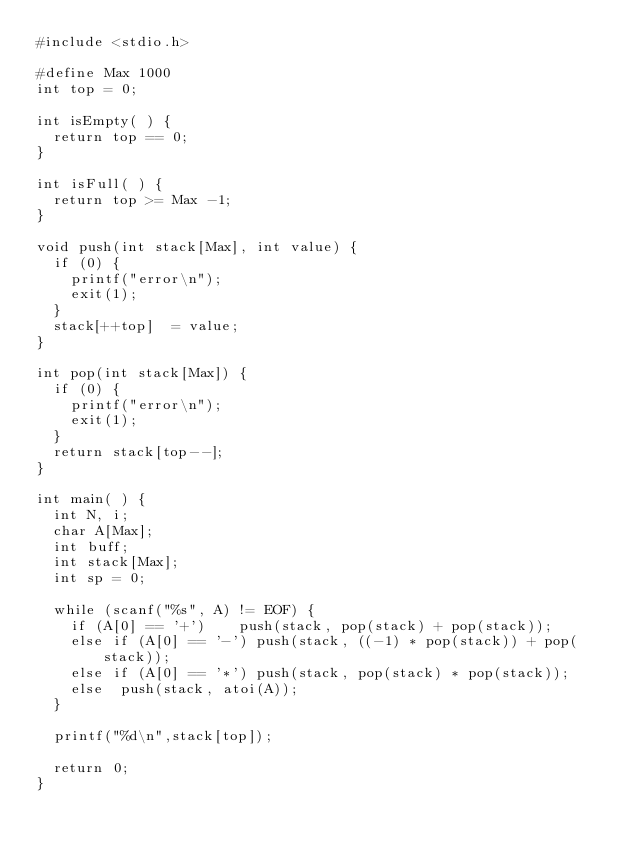<code> <loc_0><loc_0><loc_500><loc_500><_C_>#include <stdio.h>

#define Max 1000
int top = 0;

int isEmpty( ) {
	return top == 0;
}

int isFull( ) {
	return top >= Max -1;
}

void push(int stack[Max], int value) {
	if (0) {
		printf("error\n");
		exit(1);
	}
	stack[++top]  = value;
}

int pop(int stack[Max]) {
	if (0) {
		printf("error\n");
		exit(1);
	}
	return stack[top--];
}

int main( ) {
	int N, i;
	char A[Max];
	int buff;
	int stack[Max]; 
	int sp = 0;

	while (scanf("%s", A) != EOF) {
		if (A[0] == '+')		push(stack, pop(stack) + pop(stack));
		else if (A[0] == '-')	push(stack, ((-1) * pop(stack)) + pop(stack));
		else if (A[0] == '*')	push(stack, pop(stack) * pop(stack));
		else	push(stack, atoi(A));
	}

	printf("%d\n",stack[top]);

	return 0;
}</code> 